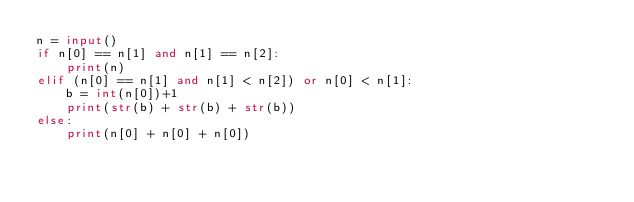Convert code to text. <code><loc_0><loc_0><loc_500><loc_500><_Python_>n = input()
if n[0] == n[1] and n[1] == n[2]:
    print(n)
elif (n[0] == n[1] and n[1] < n[2]) or n[0] < n[1]:
    b = int(n[0])+1
    print(str(b) + str(b) + str(b))
else:
    print(n[0] + n[0] + n[0])</code> 